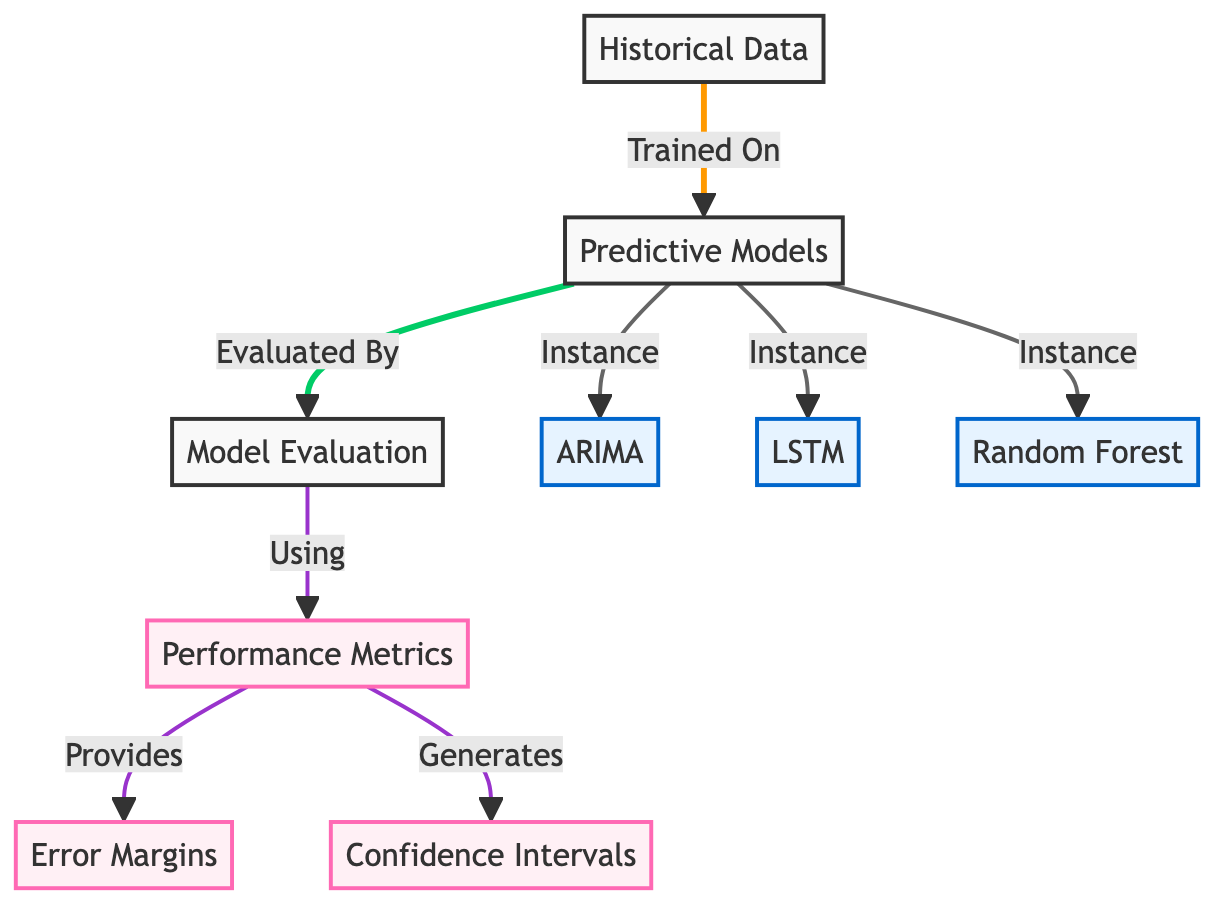What are the predictive models mentioned in the diagram? The diagram lists three predictive models: ARIMA, LSTM, and Random Forest. This information is directly visible under the "Predictive Models" section connected to the instances.
Answer: ARIMA, LSTM, Random Forest How many performance metrics are illustrated in the diagram? There is one node labeled "Performance Metrics," which connects to "Error Margins" and "Confidence Intervals." This indicates that there is only one category of performance metrics shown.
Answer: One What do the performance metrics provide in the evaluation process? The diagram shows that performance metrics provide error margins, as indicated by the directed link between "Performance Metrics" and "Error Margins."
Answer: Error Margins Which model is evaluated in the diagram based on historical data? All three models (ARIMA, LSTM, Random Forest) are evaluated under the "Predictive Models" category that is connected to the "Model Evaluation" node, which indicates they are all included.
Answer: Three What type of diagram is represented? The structure and labels indicate that this is a flowchart that visually represents a comparative analysis of predictive model performance. It organizes and categorizes the process of evaluation.
Answer: Flowchart What are the two outputs generated from the performance metrics? The diagram shows that performance metrics generate both error margins and confidence intervals. These outputs are directly connected as a result of the evaluation process.
Answer: Error Margins and Confidence Intervals What is the role of historical data in the predictive modeling process? Historical data serves as the foundational input, as indicated by the arrow from "Historical Data" to "Predictive Models," suggesting it is essential for training the models.
Answer: Training Input Which node connects the predictive models to the model evaluation? The node labeled "Model Evaluation" is connected to "Predictive Models" through a direct arrow indicating that the evaluation is based on those models.
Answer: Model Evaluation 